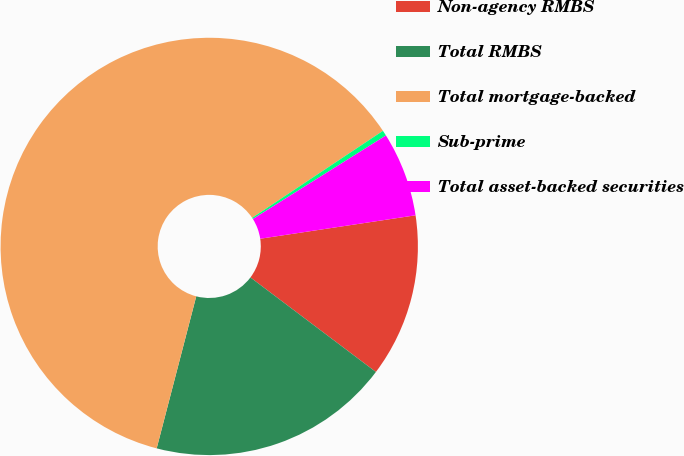Convert chart. <chart><loc_0><loc_0><loc_500><loc_500><pie_chart><fcel>Non-agency RMBS<fcel>Total RMBS<fcel>Total mortgage-backed<fcel>Sub-prime<fcel>Total asset-backed securities<nl><fcel>12.66%<fcel>18.78%<fcel>61.61%<fcel>0.42%<fcel>6.54%<nl></chart> 